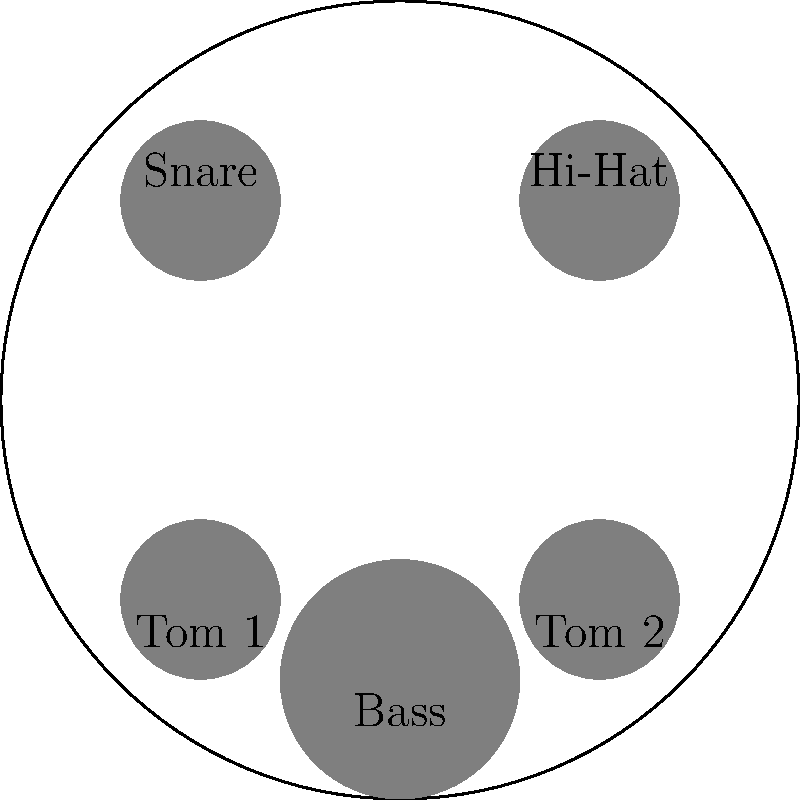As a rock drummer, you're experimenting with different drum kit arrangements. The diagram shows a standard 5-piece drum kit setup. How many unique arrangements can be created by rotating and reflecting this setup, assuming the bass drum stays fixed in its position? Let's approach this step-by-step:

1) First, we need to identify the symmetries of the drum kit arrangement:
   - The bass drum is fixed, so we only consider the other four pieces.
   - The arrangement has rotational symmetry of order 2 (180° rotation).
   - It also has two reflection symmetries: across the vertical and horizontal axes.

2) These symmetries form the dihedral group $D_2$, also known as the Klein four-group.

3) The order of the $D_2$ group is 4. This means there are 4 symmetry operations:
   - Identity (no change)
   - 180° rotation
   - Reflection across the vertical axis
   - Reflection across the horizontal axis

4) Each of these operations produces a unique arrangement of the drum kit.

5) Therefore, the number of unique arrangements is equal to the order of the $D_2$ group, which is 4.

This result aligns with a rock drummer's practical understanding of kit setup variations, focusing on the fundamental symmetries without unnecessary complexities.
Answer: 4 unique arrangements 